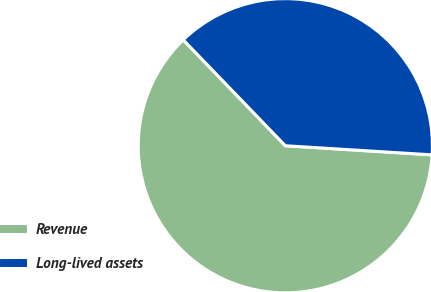Convert chart to OTSL. <chart><loc_0><loc_0><loc_500><loc_500><pie_chart><fcel>Revenue<fcel>Long-lived assets<nl><fcel>61.8%<fcel>38.2%<nl></chart> 